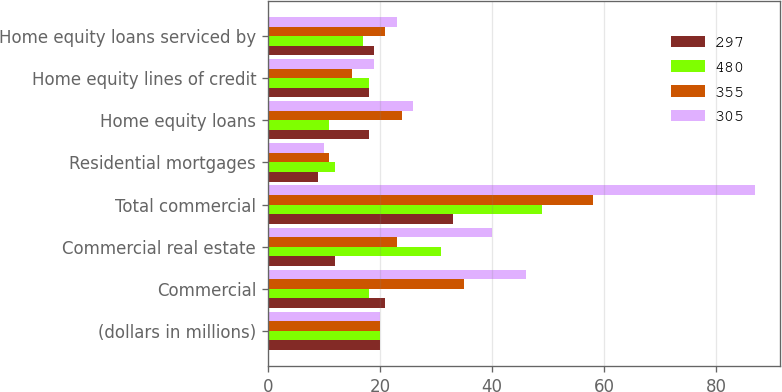Convert chart to OTSL. <chart><loc_0><loc_0><loc_500><loc_500><stacked_bar_chart><ecel><fcel>(dollars in millions)<fcel>Commercial<fcel>Commercial real estate<fcel>Total commercial<fcel>Residential mortgages<fcel>Home equity loans<fcel>Home equity lines of credit<fcel>Home equity loans serviced by<nl><fcel>297<fcel>20<fcel>21<fcel>12<fcel>33<fcel>9<fcel>18<fcel>18<fcel>19<nl><fcel>480<fcel>20<fcel>18<fcel>31<fcel>49<fcel>12<fcel>11<fcel>18<fcel>17<nl><fcel>355<fcel>20<fcel>35<fcel>23<fcel>58<fcel>11<fcel>24<fcel>15<fcel>21<nl><fcel>305<fcel>20<fcel>46<fcel>40<fcel>87<fcel>10<fcel>26<fcel>19<fcel>23<nl></chart> 